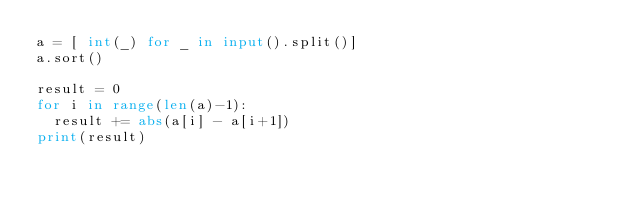Convert code to text. <code><loc_0><loc_0><loc_500><loc_500><_Python_>a = [ int(_) for _ in input().split()]
a.sort()

result = 0
for i in range(len(a)-1):
  result += abs(a[i] - a[i+1])
print(result)</code> 